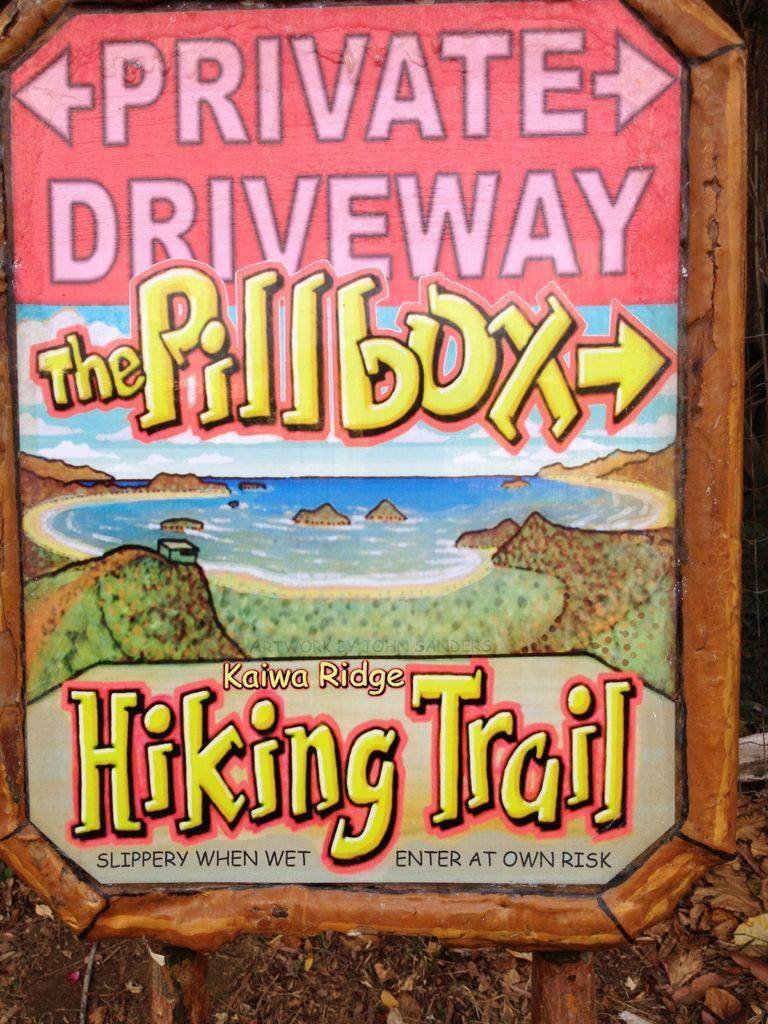<image>
Create a compact narrative representing the image presented. A sign that says the way to the pillbox hiking trail 